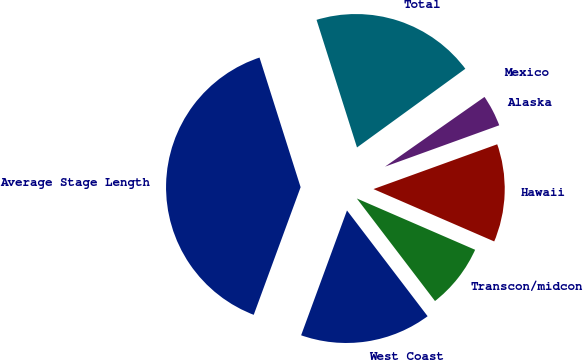Convert chart to OTSL. <chart><loc_0><loc_0><loc_500><loc_500><pie_chart><fcel>West Coast<fcel>Transcon/midcon<fcel>Hawaii<fcel>Alaska<fcel>Mexico<fcel>Total<fcel>Average Stage Length<nl><fcel>15.97%<fcel>8.12%<fcel>12.04%<fcel>4.2%<fcel>0.27%<fcel>19.89%<fcel>39.51%<nl></chart> 